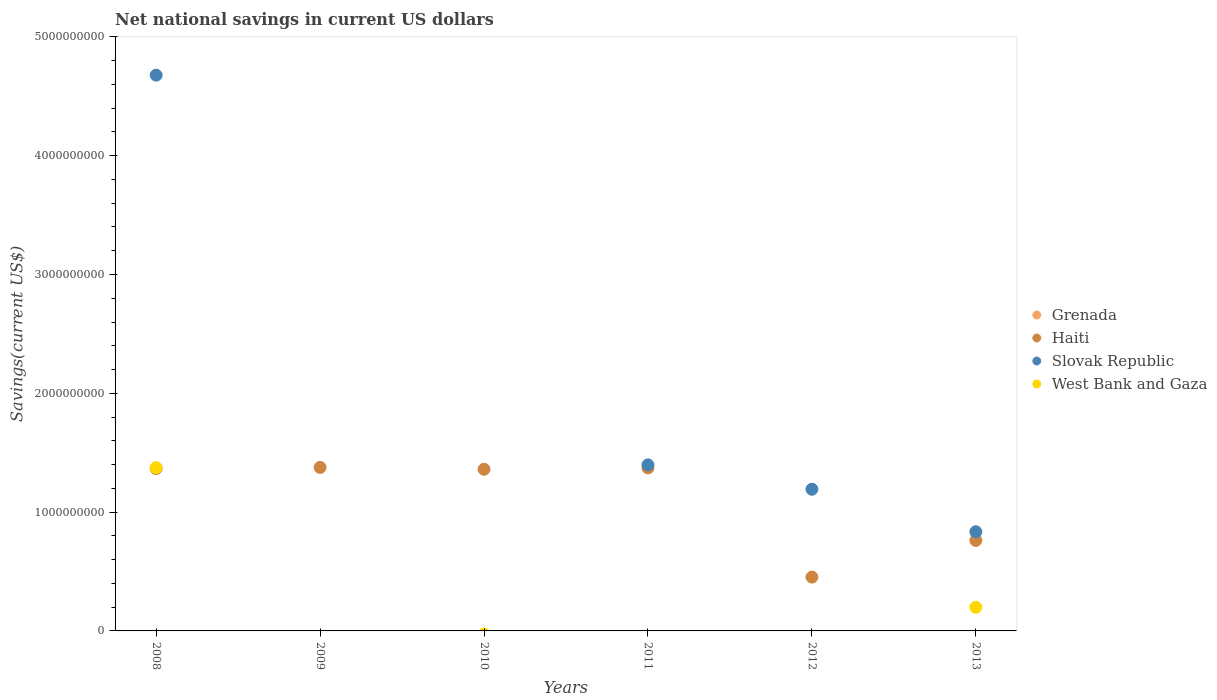How many different coloured dotlines are there?
Make the answer very short. 3. Is the number of dotlines equal to the number of legend labels?
Your response must be concise. No. Across all years, what is the maximum net national savings in Slovak Republic?
Keep it short and to the point. 4.68e+09. What is the total net national savings in West Bank and Gaza in the graph?
Keep it short and to the point. 1.57e+09. What is the difference between the net national savings in Slovak Republic in 2011 and that in 2012?
Provide a short and direct response. 2.05e+08. What is the difference between the net national savings in Grenada in 2008 and the net national savings in West Bank and Gaza in 2010?
Provide a short and direct response. 0. What is the average net national savings in Haiti per year?
Offer a terse response. 1.11e+09. In the year 2012, what is the difference between the net national savings in Haiti and net national savings in Slovak Republic?
Your answer should be very brief. -7.39e+08. In how many years, is the net national savings in Grenada greater than 3000000000 US$?
Offer a terse response. 0. What is the ratio of the net national savings in Haiti in 2009 to that in 2012?
Keep it short and to the point. 3.04. What is the difference between the highest and the second highest net national savings in Haiti?
Ensure brevity in your answer.  3.62e+06. What is the difference between the highest and the lowest net national savings in Haiti?
Offer a terse response. 9.23e+08. Is it the case that in every year, the sum of the net national savings in West Bank and Gaza and net national savings in Grenada  is greater than the sum of net national savings in Slovak Republic and net national savings in Haiti?
Offer a terse response. No. Is it the case that in every year, the sum of the net national savings in West Bank and Gaza and net national savings in Haiti  is greater than the net national savings in Slovak Republic?
Give a very brief answer. No. Is the net national savings in West Bank and Gaza strictly greater than the net national savings in Haiti over the years?
Your answer should be very brief. No. How many dotlines are there?
Keep it short and to the point. 3. What is the difference between two consecutive major ticks on the Y-axis?
Offer a very short reply. 1.00e+09. Where does the legend appear in the graph?
Provide a short and direct response. Center right. How many legend labels are there?
Make the answer very short. 4. What is the title of the graph?
Provide a short and direct response. Net national savings in current US dollars. What is the label or title of the X-axis?
Your answer should be very brief. Years. What is the label or title of the Y-axis?
Give a very brief answer. Savings(current US$). What is the Savings(current US$) of Haiti in 2008?
Give a very brief answer. 1.37e+09. What is the Savings(current US$) of Slovak Republic in 2008?
Your answer should be compact. 4.68e+09. What is the Savings(current US$) of West Bank and Gaza in 2008?
Your answer should be compact. 1.37e+09. What is the Savings(current US$) of Haiti in 2009?
Provide a succinct answer. 1.38e+09. What is the Savings(current US$) in Slovak Republic in 2009?
Your answer should be compact. 0. What is the Savings(current US$) of Haiti in 2010?
Make the answer very short. 1.36e+09. What is the Savings(current US$) in Slovak Republic in 2010?
Keep it short and to the point. 0. What is the Savings(current US$) in Grenada in 2011?
Make the answer very short. 0. What is the Savings(current US$) of Haiti in 2011?
Make the answer very short. 1.37e+09. What is the Savings(current US$) in Slovak Republic in 2011?
Ensure brevity in your answer.  1.40e+09. What is the Savings(current US$) of Grenada in 2012?
Your answer should be very brief. 0. What is the Savings(current US$) in Haiti in 2012?
Ensure brevity in your answer.  4.53e+08. What is the Savings(current US$) in Slovak Republic in 2012?
Your answer should be compact. 1.19e+09. What is the Savings(current US$) in West Bank and Gaza in 2012?
Make the answer very short. 0. What is the Savings(current US$) in Haiti in 2013?
Make the answer very short. 7.62e+08. What is the Savings(current US$) of Slovak Republic in 2013?
Provide a short and direct response. 8.35e+08. What is the Savings(current US$) in West Bank and Gaza in 2013?
Your answer should be compact. 1.99e+08. Across all years, what is the maximum Savings(current US$) in Haiti?
Your answer should be compact. 1.38e+09. Across all years, what is the maximum Savings(current US$) of Slovak Republic?
Keep it short and to the point. 4.68e+09. Across all years, what is the maximum Savings(current US$) of West Bank and Gaza?
Offer a very short reply. 1.37e+09. Across all years, what is the minimum Savings(current US$) of Haiti?
Offer a very short reply. 4.53e+08. Across all years, what is the minimum Savings(current US$) in West Bank and Gaza?
Give a very brief answer. 0. What is the total Savings(current US$) of Haiti in the graph?
Your answer should be very brief. 6.69e+09. What is the total Savings(current US$) of Slovak Republic in the graph?
Your response must be concise. 8.10e+09. What is the total Savings(current US$) of West Bank and Gaza in the graph?
Ensure brevity in your answer.  1.57e+09. What is the difference between the Savings(current US$) in Haiti in 2008 and that in 2009?
Offer a very short reply. -9.73e+06. What is the difference between the Savings(current US$) in Haiti in 2008 and that in 2010?
Offer a terse response. 5.82e+06. What is the difference between the Savings(current US$) of Haiti in 2008 and that in 2011?
Give a very brief answer. -6.11e+06. What is the difference between the Savings(current US$) in Slovak Republic in 2008 and that in 2011?
Offer a terse response. 3.28e+09. What is the difference between the Savings(current US$) in Haiti in 2008 and that in 2012?
Your response must be concise. 9.13e+08. What is the difference between the Savings(current US$) of Slovak Republic in 2008 and that in 2012?
Your response must be concise. 3.49e+09. What is the difference between the Savings(current US$) of Haiti in 2008 and that in 2013?
Provide a succinct answer. 6.05e+08. What is the difference between the Savings(current US$) in Slovak Republic in 2008 and that in 2013?
Offer a very short reply. 3.84e+09. What is the difference between the Savings(current US$) in West Bank and Gaza in 2008 and that in 2013?
Offer a very short reply. 1.18e+09. What is the difference between the Savings(current US$) of Haiti in 2009 and that in 2010?
Provide a short and direct response. 1.55e+07. What is the difference between the Savings(current US$) of Haiti in 2009 and that in 2011?
Provide a short and direct response. 3.62e+06. What is the difference between the Savings(current US$) of Haiti in 2009 and that in 2012?
Provide a succinct answer. 9.23e+08. What is the difference between the Savings(current US$) of Haiti in 2009 and that in 2013?
Keep it short and to the point. 6.14e+08. What is the difference between the Savings(current US$) of Haiti in 2010 and that in 2011?
Your answer should be compact. -1.19e+07. What is the difference between the Savings(current US$) of Haiti in 2010 and that in 2012?
Your response must be concise. 9.07e+08. What is the difference between the Savings(current US$) of Haiti in 2010 and that in 2013?
Give a very brief answer. 5.99e+08. What is the difference between the Savings(current US$) in Haiti in 2011 and that in 2012?
Ensure brevity in your answer.  9.19e+08. What is the difference between the Savings(current US$) of Slovak Republic in 2011 and that in 2012?
Your response must be concise. 2.05e+08. What is the difference between the Savings(current US$) of Haiti in 2011 and that in 2013?
Keep it short and to the point. 6.11e+08. What is the difference between the Savings(current US$) of Slovak Republic in 2011 and that in 2013?
Offer a very short reply. 5.63e+08. What is the difference between the Savings(current US$) in Haiti in 2012 and that in 2013?
Keep it short and to the point. -3.09e+08. What is the difference between the Savings(current US$) of Slovak Republic in 2012 and that in 2013?
Provide a short and direct response. 3.57e+08. What is the difference between the Savings(current US$) in Haiti in 2008 and the Savings(current US$) in Slovak Republic in 2011?
Keep it short and to the point. -3.14e+07. What is the difference between the Savings(current US$) in Haiti in 2008 and the Savings(current US$) in Slovak Republic in 2012?
Offer a terse response. 1.74e+08. What is the difference between the Savings(current US$) of Haiti in 2008 and the Savings(current US$) of Slovak Republic in 2013?
Offer a very short reply. 5.31e+08. What is the difference between the Savings(current US$) of Haiti in 2008 and the Savings(current US$) of West Bank and Gaza in 2013?
Keep it short and to the point. 1.17e+09. What is the difference between the Savings(current US$) in Slovak Republic in 2008 and the Savings(current US$) in West Bank and Gaza in 2013?
Ensure brevity in your answer.  4.48e+09. What is the difference between the Savings(current US$) of Haiti in 2009 and the Savings(current US$) of Slovak Republic in 2011?
Your answer should be compact. -2.17e+07. What is the difference between the Savings(current US$) in Haiti in 2009 and the Savings(current US$) in Slovak Republic in 2012?
Keep it short and to the point. 1.84e+08. What is the difference between the Savings(current US$) in Haiti in 2009 and the Savings(current US$) in Slovak Republic in 2013?
Your response must be concise. 5.41e+08. What is the difference between the Savings(current US$) in Haiti in 2009 and the Savings(current US$) in West Bank and Gaza in 2013?
Your response must be concise. 1.18e+09. What is the difference between the Savings(current US$) in Haiti in 2010 and the Savings(current US$) in Slovak Republic in 2011?
Your answer should be compact. -3.72e+07. What is the difference between the Savings(current US$) of Haiti in 2010 and the Savings(current US$) of Slovak Republic in 2012?
Offer a terse response. 1.68e+08. What is the difference between the Savings(current US$) of Haiti in 2010 and the Savings(current US$) of Slovak Republic in 2013?
Offer a very short reply. 5.25e+08. What is the difference between the Savings(current US$) of Haiti in 2010 and the Savings(current US$) of West Bank and Gaza in 2013?
Give a very brief answer. 1.16e+09. What is the difference between the Savings(current US$) of Haiti in 2011 and the Savings(current US$) of Slovak Republic in 2012?
Keep it short and to the point. 1.80e+08. What is the difference between the Savings(current US$) in Haiti in 2011 and the Savings(current US$) in Slovak Republic in 2013?
Make the answer very short. 5.37e+08. What is the difference between the Savings(current US$) in Haiti in 2011 and the Savings(current US$) in West Bank and Gaza in 2013?
Provide a succinct answer. 1.17e+09. What is the difference between the Savings(current US$) of Slovak Republic in 2011 and the Savings(current US$) of West Bank and Gaza in 2013?
Your answer should be compact. 1.20e+09. What is the difference between the Savings(current US$) of Haiti in 2012 and the Savings(current US$) of Slovak Republic in 2013?
Your answer should be very brief. -3.82e+08. What is the difference between the Savings(current US$) of Haiti in 2012 and the Savings(current US$) of West Bank and Gaza in 2013?
Offer a terse response. 2.54e+08. What is the difference between the Savings(current US$) of Slovak Republic in 2012 and the Savings(current US$) of West Bank and Gaza in 2013?
Keep it short and to the point. 9.94e+08. What is the average Savings(current US$) of Grenada per year?
Your answer should be very brief. 0. What is the average Savings(current US$) of Haiti per year?
Ensure brevity in your answer.  1.11e+09. What is the average Savings(current US$) of Slovak Republic per year?
Your response must be concise. 1.35e+09. What is the average Savings(current US$) of West Bank and Gaza per year?
Offer a terse response. 2.62e+08. In the year 2008, what is the difference between the Savings(current US$) of Haiti and Savings(current US$) of Slovak Republic?
Your response must be concise. -3.31e+09. In the year 2008, what is the difference between the Savings(current US$) in Haiti and Savings(current US$) in West Bank and Gaza?
Provide a succinct answer. -7.66e+06. In the year 2008, what is the difference between the Savings(current US$) of Slovak Republic and Savings(current US$) of West Bank and Gaza?
Give a very brief answer. 3.30e+09. In the year 2011, what is the difference between the Savings(current US$) of Haiti and Savings(current US$) of Slovak Republic?
Give a very brief answer. -2.53e+07. In the year 2012, what is the difference between the Savings(current US$) of Haiti and Savings(current US$) of Slovak Republic?
Your answer should be compact. -7.39e+08. In the year 2013, what is the difference between the Savings(current US$) of Haiti and Savings(current US$) of Slovak Republic?
Make the answer very short. -7.34e+07. In the year 2013, what is the difference between the Savings(current US$) of Haiti and Savings(current US$) of West Bank and Gaza?
Your response must be concise. 5.63e+08. In the year 2013, what is the difference between the Savings(current US$) in Slovak Republic and Savings(current US$) in West Bank and Gaza?
Offer a very short reply. 6.36e+08. What is the ratio of the Savings(current US$) of Haiti in 2008 to that in 2010?
Provide a short and direct response. 1. What is the ratio of the Savings(current US$) in Slovak Republic in 2008 to that in 2011?
Give a very brief answer. 3.35. What is the ratio of the Savings(current US$) in Haiti in 2008 to that in 2012?
Keep it short and to the point. 3.02. What is the ratio of the Savings(current US$) of Slovak Republic in 2008 to that in 2012?
Your answer should be compact. 3.92. What is the ratio of the Savings(current US$) of Haiti in 2008 to that in 2013?
Offer a terse response. 1.79. What is the ratio of the Savings(current US$) in Slovak Republic in 2008 to that in 2013?
Provide a short and direct response. 5.6. What is the ratio of the Savings(current US$) of West Bank and Gaza in 2008 to that in 2013?
Your answer should be very brief. 6.91. What is the ratio of the Savings(current US$) of Haiti in 2009 to that in 2010?
Provide a short and direct response. 1.01. What is the ratio of the Savings(current US$) in Haiti in 2009 to that in 2012?
Make the answer very short. 3.04. What is the ratio of the Savings(current US$) of Haiti in 2009 to that in 2013?
Provide a succinct answer. 1.81. What is the ratio of the Savings(current US$) in Haiti in 2010 to that in 2012?
Give a very brief answer. 3. What is the ratio of the Savings(current US$) of Haiti in 2010 to that in 2013?
Provide a short and direct response. 1.79. What is the ratio of the Savings(current US$) of Haiti in 2011 to that in 2012?
Ensure brevity in your answer.  3.03. What is the ratio of the Savings(current US$) of Slovak Republic in 2011 to that in 2012?
Your response must be concise. 1.17. What is the ratio of the Savings(current US$) of Haiti in 2011 to that in 2013?
Keep it short and to the point. 1.8. What is the ratio of the Savings(current US$) of Slovak Republic in 2011 to that in 2013?
Your answer should be very brief. 1.67. What is the ratio of the Savings(current US$) of Haiti in 2012 to that in 2013?
Offer a very short reply. 0.59. What is the ratio of the Savings(current US$) of Slovak Republic in 2012 to that in 2013?
Your answer should be very brief. 1.43. What is the difference between the highest and the second highest Savings(current US$) in Haiti?
Ensure brevity in your answer.  3.62e+06. What is the difference between the highest and the second highest Savings(current US$) of Slovak Republic?
Ensure brevity in your answer.  3.28e+09. What is the difference between the highest and the lowest Savings(current US$) in Haiti?
Offer a terse response. 9.23e+08. What is the difference between the highest and the lowest Savings(current US$) in Slovak Republic?
Provide a succinct answer. 4.68e+09. What is the difference between the highest and the lowest Savings(current US$) in West Bank and Gaza?
Ensure brevity in your answer.  1.37e+09. 